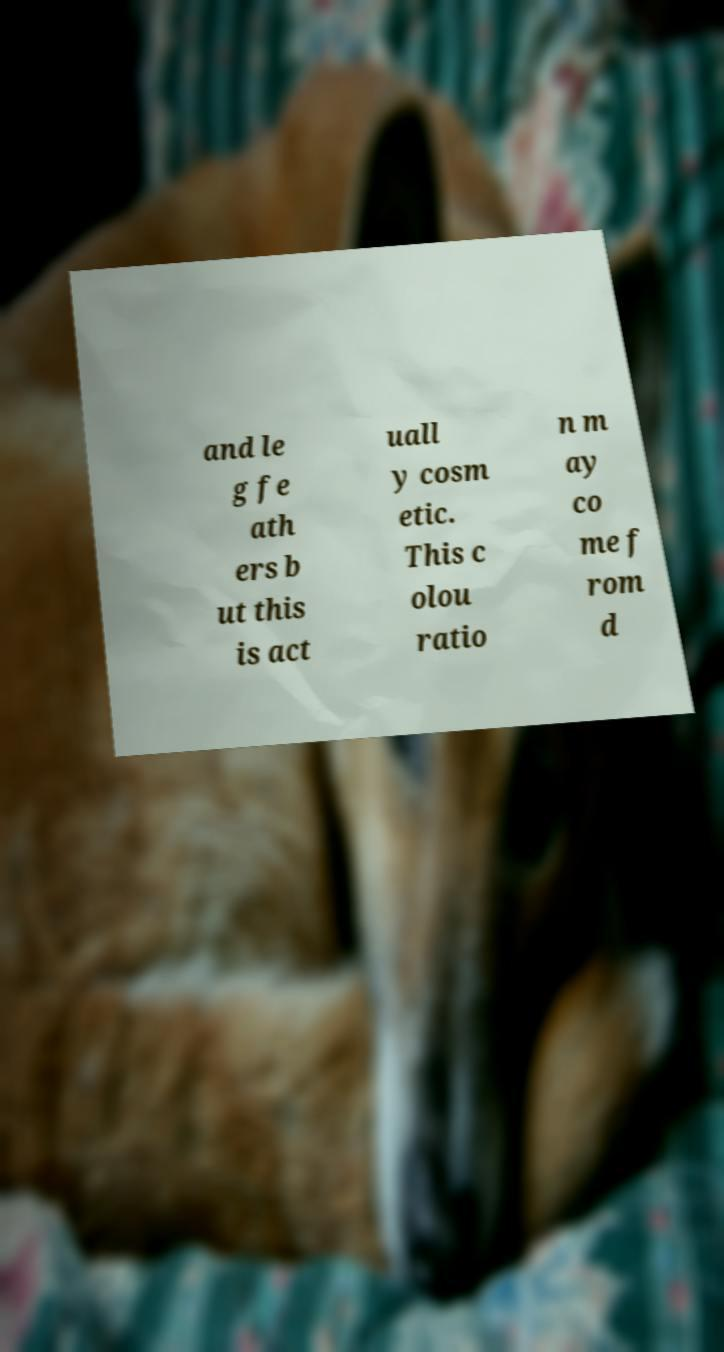I need the written content from this picture converted into text. Can you do that? and le g fe ath ers b ut this is act uall y cosm etic. This c olou ratio n m ay co me f rom d 